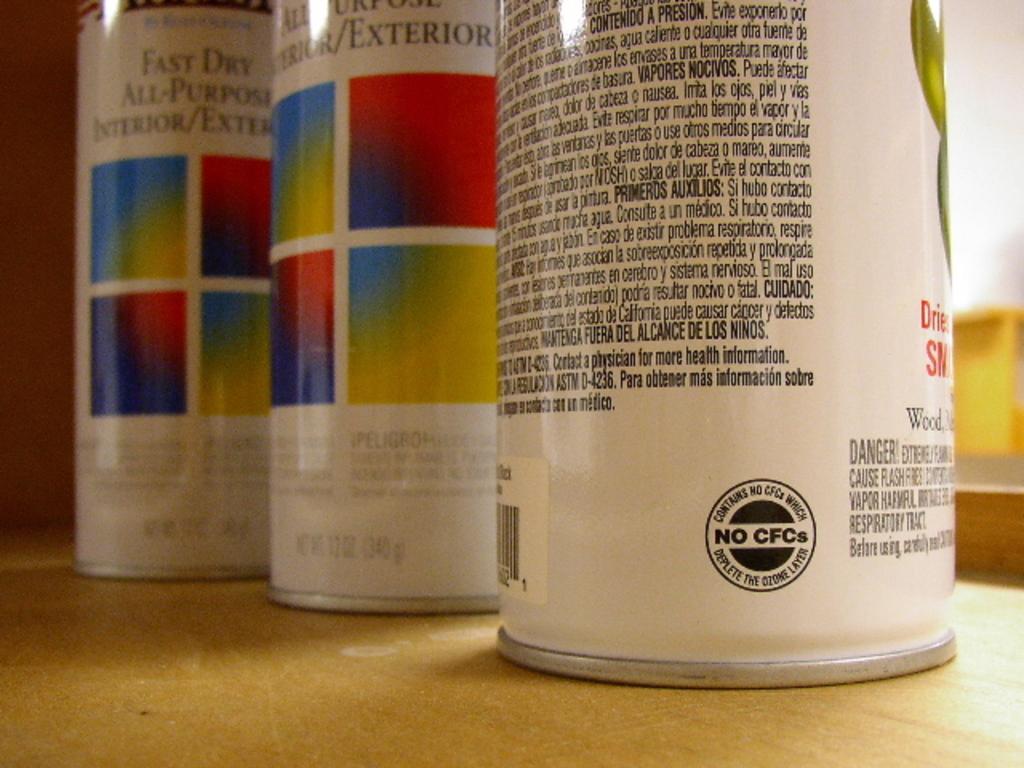What does it say in the middle of the black circle?
Offer a terse response. No cfcs. 